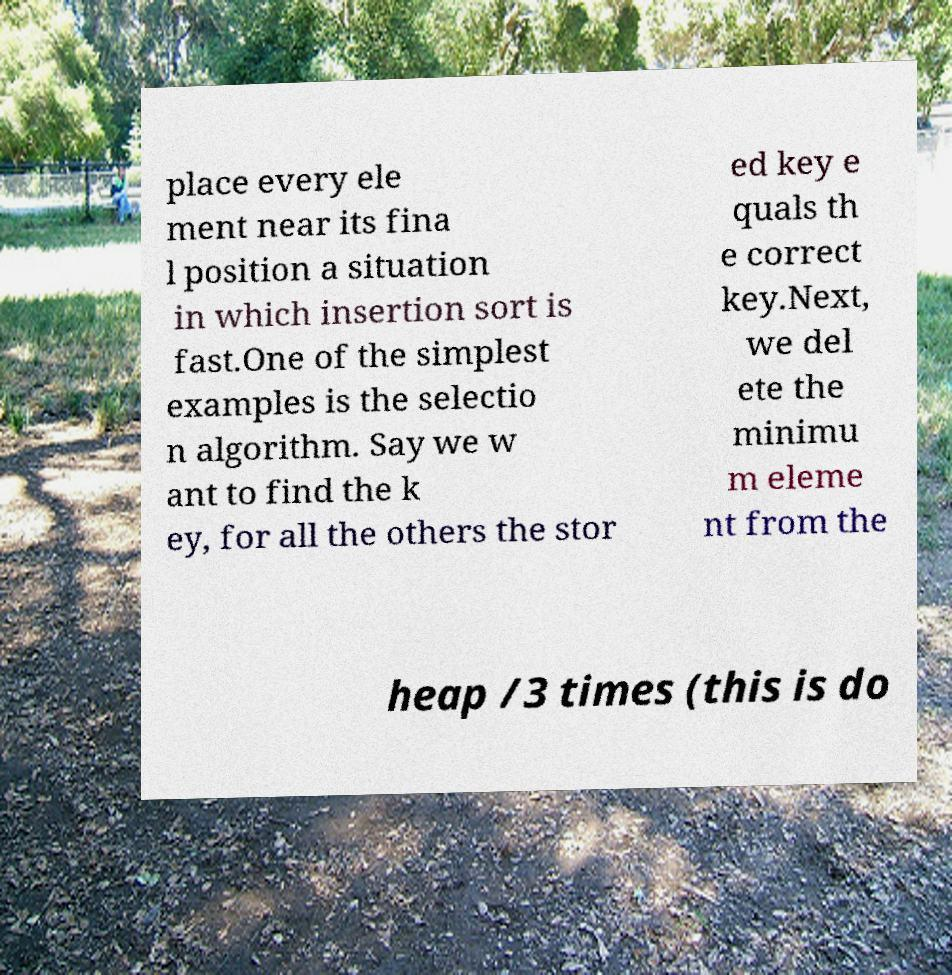Please identify and transcribe the text found in this image. place every ele ment near its fina l position a situation in which insertion sort is fast.One of the simplest examples is the selectio n algorithm. Say we w ant to find the k ey, for all the others the stor ed key e quals th e correct key.Next, we del ete the minimu m eleme nt from the heap /3 times (this is do 